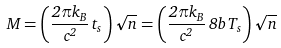Convert formula to latex. <formula><loc_0><loc_0><loc_500><loc_500>M = \left ( \frac { 2 \pi k _ { B } } { c ^ { 2 } } \, t _ { s } \right ) \sqrt { n } = \left ( \frac { 2 \pi k _ { B } } { c ^ { 2 } } \, 8 b \, T _ { s } \right ) \sqrt { n }</formula> 